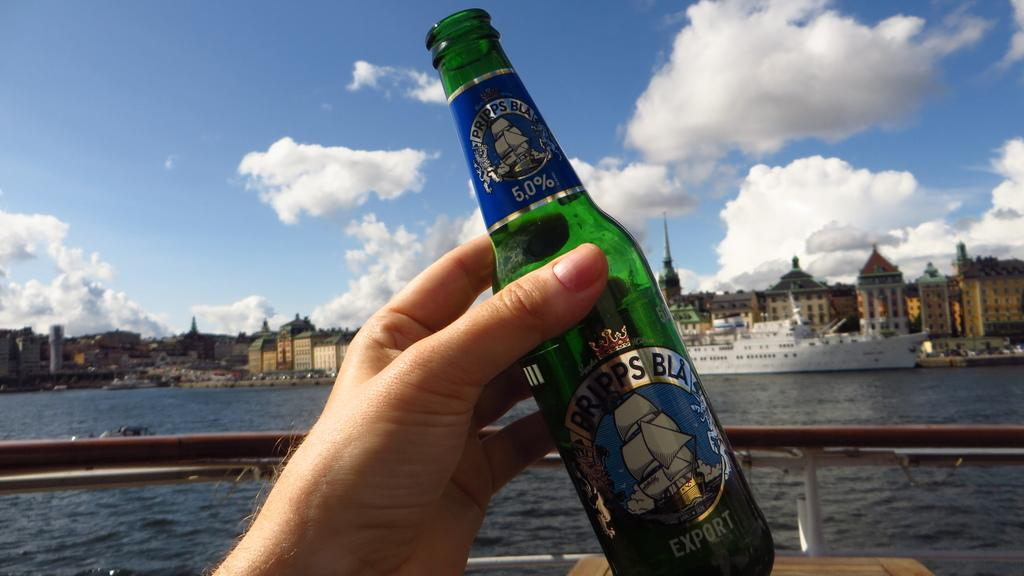<image>
Share a concise interpretation of the image provided. Bripps BLA type beer bottle that a hand is holding up on a ship. 